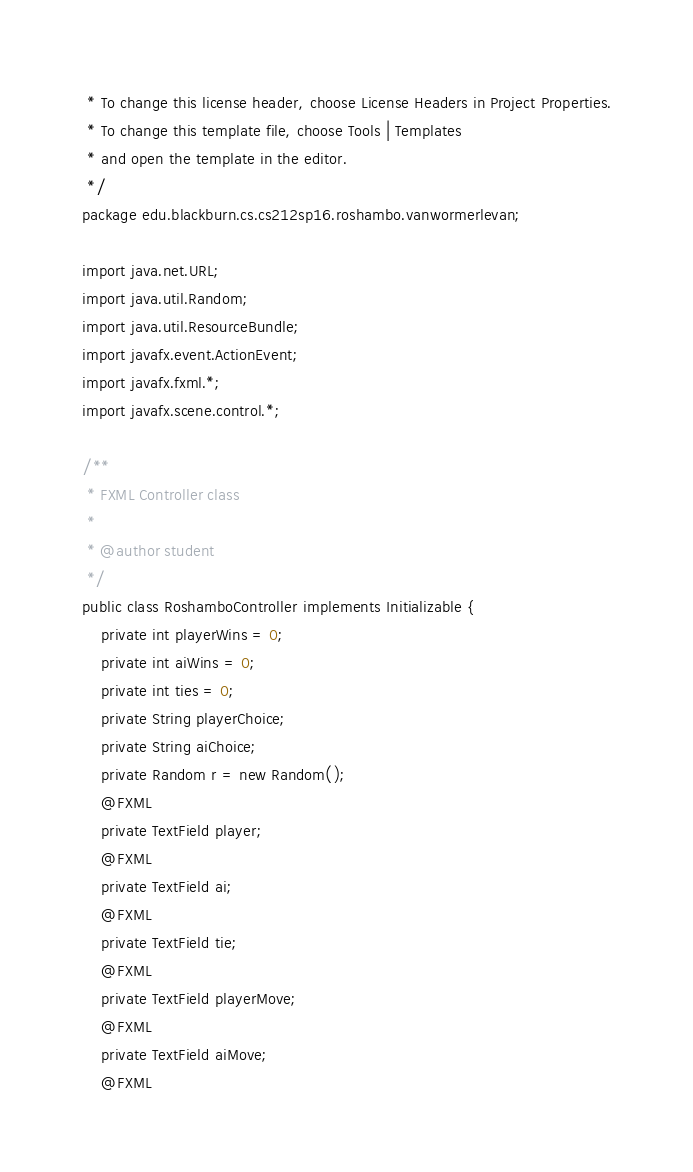<code> <loc_0><loc_0><loc_500><loc_500><_Java_> * To change this license header, choose License Headers in Project Properties.
 * To change this template file, choose Tools | Templates
 * and open the template in the editor.
 */
package edu.blackburn.cs.cs212sp16.roshambo.vanwormerlevan;

import java.net.URL;
import java.util.Random;
import java.util.ResourceBundle;
import javafx.event.ActionEvent;
import javafx.fxml.*;
import javafx.scene.control.*;

/**
 * FXML Controller class
 *
 * @author student
 */
public class RoshamboController implements Initializable {
    private int playerWins = 0;
    private int aiWins = 0;
    private int ties = 0;
    private String playerChoice;
    private String aiChoice;
    private Random r = new Random();
    @FXML
    private TextField player;
    @FXML
    private TextField ai;
    @FXML
    private TextField tie;
    @FXML
    private TextField playerMove;
    @FXML
    private TextField aiMove;
    @FXML</code> 